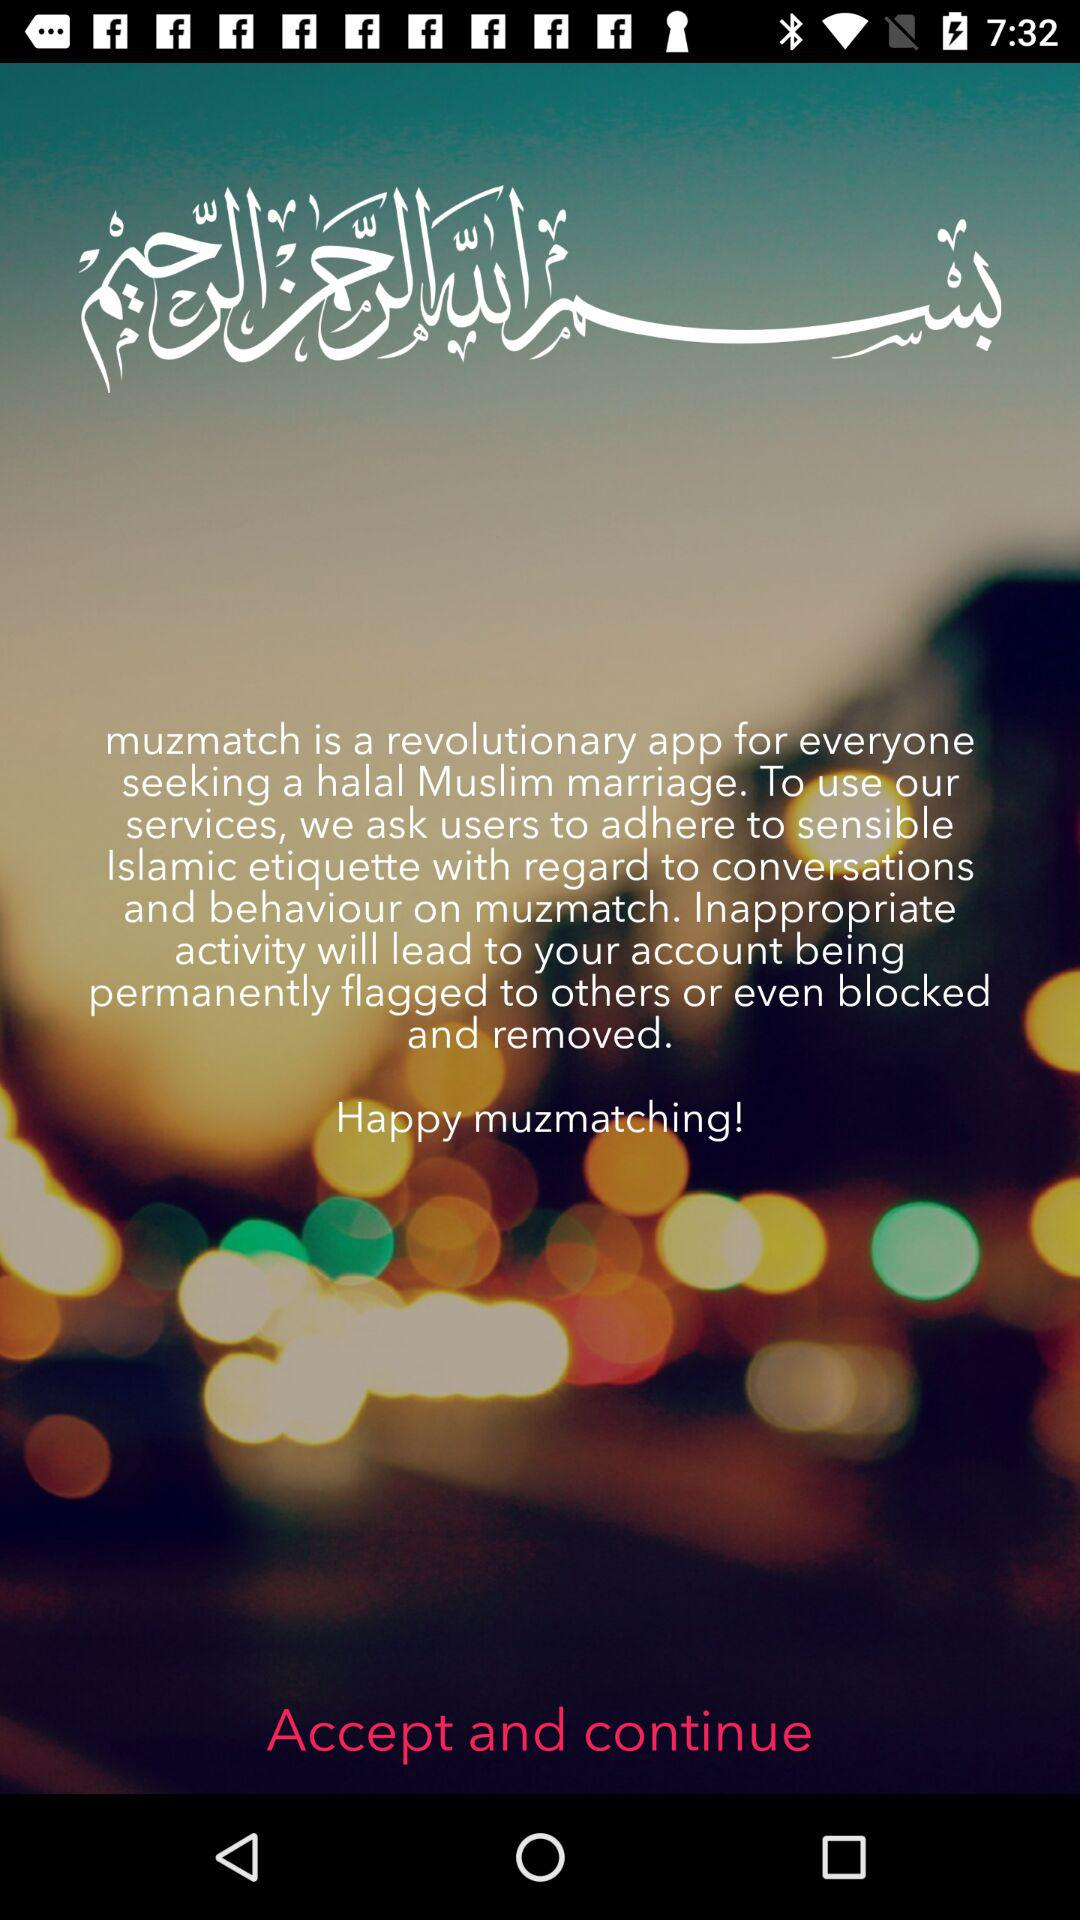What is the application name? The name of the application is "muzmatch". 